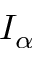Convert formula to latex. <formula><loc_0><loc_0><loc_500><loc_500>I _ { \alpha }</formula> 